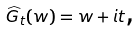Convert formula to latex. <formula><loc_0><loc_0><loc_500><loc_500>\widehat { G } _ { t } ( w ) = w + i t \text {,}</formula> 